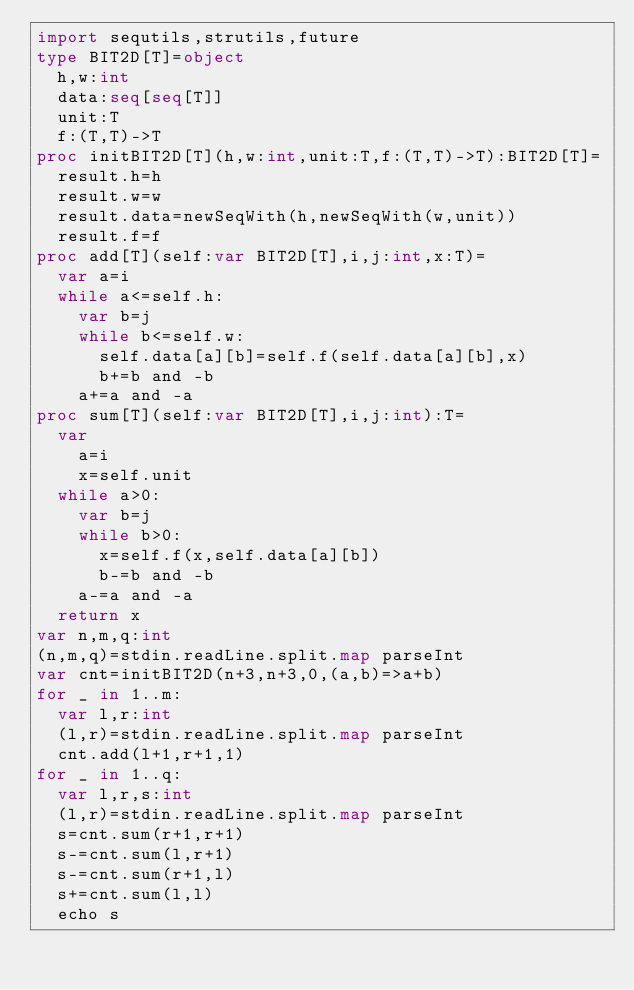Convert code to text. <code><loc_0><loc_0><loc_500><loc_500><_Nim_>import sequtils,strutils,future
type BIT2D[T]=object
  h,w:int
  data:seq[seq[T]]
  unit:T
  f:(T,T)->T
proc initBIT2D[T](h,w:int,unit:T,f:(T,T)->T):BIT2D[T]=
  result.h=h
  result.w=w
  result.data=newSeqWith(h,newSeqWith(w,unit))
  result.f=f
proc add[T](self:var BIT2D[T],i,j:int,x:T)=
  var a=i
  while a<=self.h:
    var b=j
    while b<=self.w:
      self.data[a][b]=self.f(self.data[a][b],x)
      b+=b and -b
    a+=a and -a
proc sum[T](self:var BIT2D[T],i,j:int):T=
  var
    a=i
    x=self.unit
  while a>0:
    var b=j
    while b>0:
      x=self.f(x,self.data[a][b])
      b-=b and -b
    a-=a and -a
  return x
var n,m,q:int
(n,m,q)=stdin.readLine.split.map parseInt
var cnt=initBIT2D(n+3,n+3,0,(a,b)=>a+b)
for _ in 1..m:
  var l,r:int
  (l,r)=stdin.readLine.split.map parseInt
  cnt.add(l+1,r+1,1)
for _ in 1..q:
  var l,r,s:int
  (l,r)=stdin.readLine.split.map parseInt
  s=cnt.sum(r+1,r+1)
  s-=cnt.sum(l,r+1)
  s-=cnt.sum(r+1,l)
  s+=cnt.sum(l,l)
  echo s</code> 